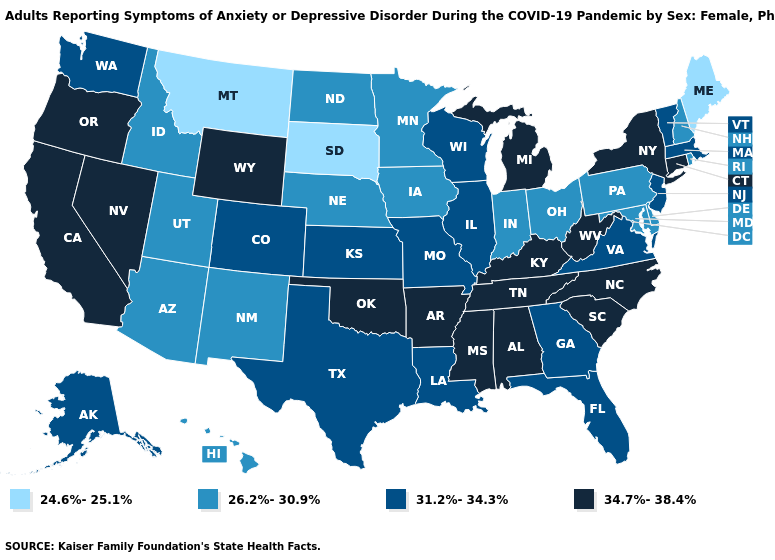What is the value of Ohio?
Quick response, please. 26.2%-30.9%. Does the first symbol in the legend represent the smallest category?
Be succinct. Yes. Name the states that have a value in the range 24.6%-25.1%?
Give a very brief answer. Maine, Montana, South Dakota. What is the value of Alaska?
Quick response, please. 31.2%-34.3%. Among the states that border Washington , which have the highest value?
Short answer required. Oregon. Name the states that have a value in the range 26.2%-30.9%?
Keep it brief. Arizona, Delaware, Hawaii, Idaho, Indiana, Iowa, Maryland, Minnesota, Nebraska, New Hampshire, New Mexico, North Dakota, Ohio, Pennsylvania, Rhode Island, Utah. What is the value of Maryland?
Answer briefly. 26.2%-30.9%. Among the states that border Kansas , does Oklahoma have the highest value?
Quick response, please. Yes. Is the legend a continuous bar?
Answer briefly. No. Name the states that have a value in the range 34.7%-38.4%?
Write a very short answer. Alabama, Arkansas, California, Connecticut, Kentucky, Michigan, Mississippi, Nevada, New York, North Carolina, Oklahoma, Oregon, South Carolina, Tennessee, West Virginia, Wyoming. What is the value of Indiana?
Quick response, please. 26.2%-30.9%. Which states have the highest value in the USA?
Give a very brief answer. Alabama, Arkansas, California, Connecticut, Kentucky, Michigan, Mississippi, Nevada, New York, North Carolina, Oklahoma, Oregon, South Carolina, Tennessee, West Virginia, Wyoming. Name the states that have a value in the range 24.6%-25.1%?
Quick response, please. Maine, Montana, South Dakota. Which states have the lowest value in the MidWest?
Keep it brief. South Dakota. Name the states that have a value in the range 24.6%-25.1%?
Concise answer only. Maine, Montana, South Dakota. 